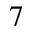Convert formula to latex. <formula><loc_0><loc_0><loc_500><loc_500>^ { 7 }</formula> 